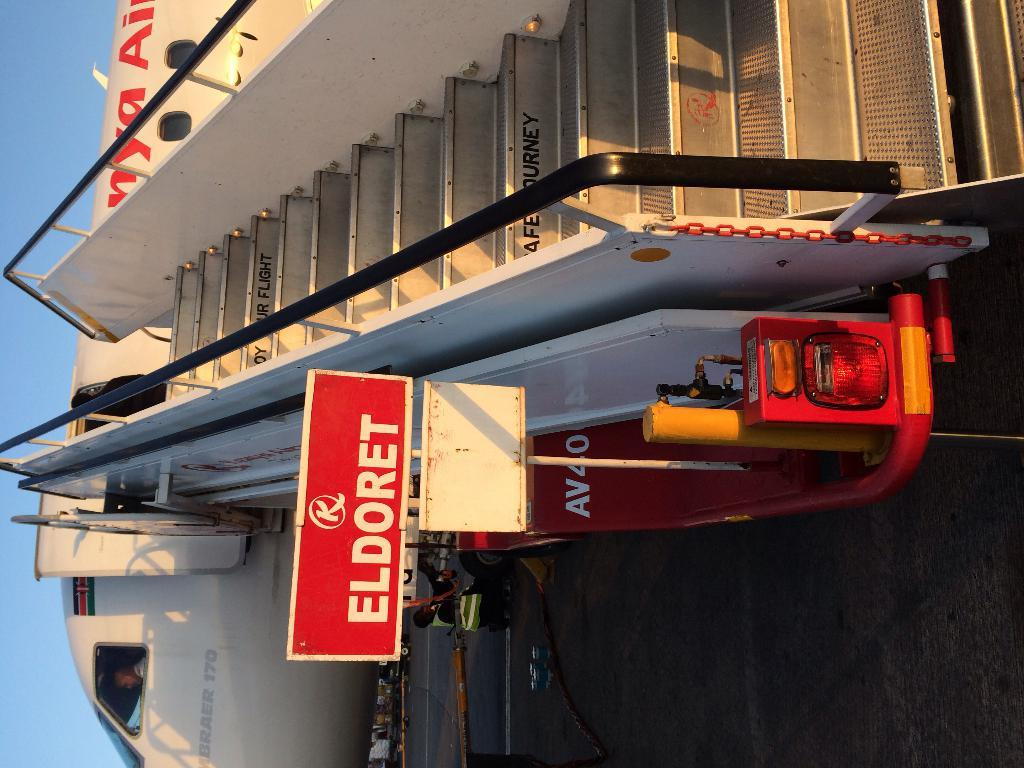<image>
Render a clear and concise summary of the photo. A portable stair ramp that says Eldoret is attached to a plane. 